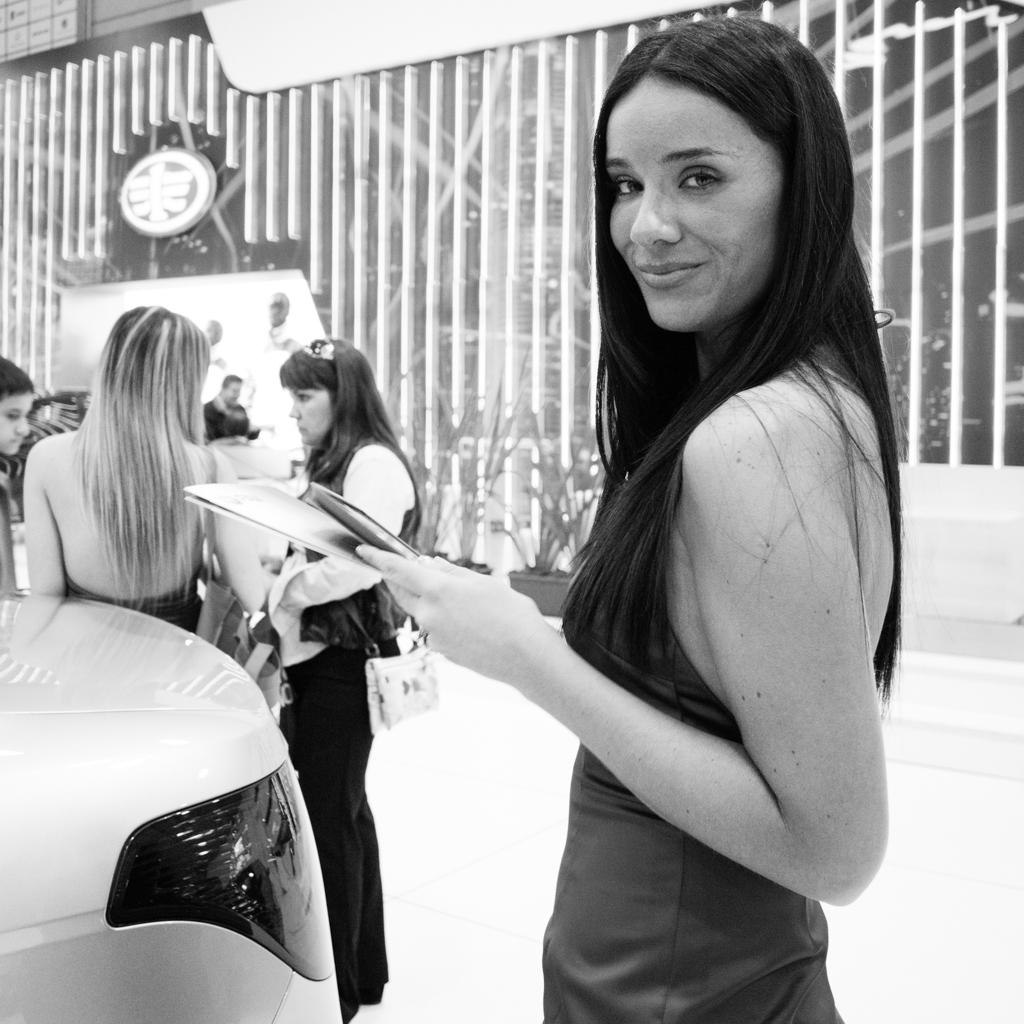How many people are in the image? There are people in the image, but the exact number is not specified. What is the lady holding in the image? The lady is holding paper in the image. What type of object can be seen in the image that is used for transportation? There is a vehicle in the image. What type of structure can be seen in the image that provides a barrier or boundary? There is a wall in the image. What type of flat surface can be seen in the image that is used for displaying information or messages? There is a board in the image. Can you see any boats in the harbor in the image? There is no harbor or boats present in the image. What type of clothing is the lady wearing in the image? The lady's clothing is not mentioned in the provided facts, so we cannot answer this question. 